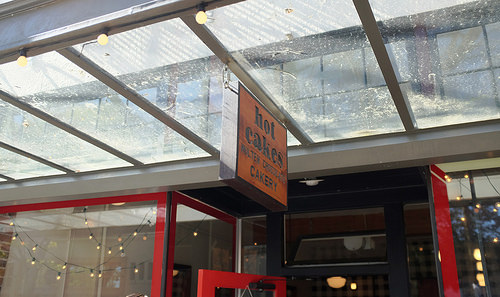<image>
Is there a sign next to the door? Yes. The sign is positioned adjacent to the door, located nearby in the same general area. 